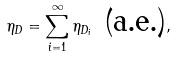Convert formula to latex. <formula><loc_0><loc_0><loc_500><loc_500>\eta _ { D } = \sum ^ { \infty } _ { i = 1 } \eta _ { D _ { i } } \text { (a.e.)} ,</formula> 